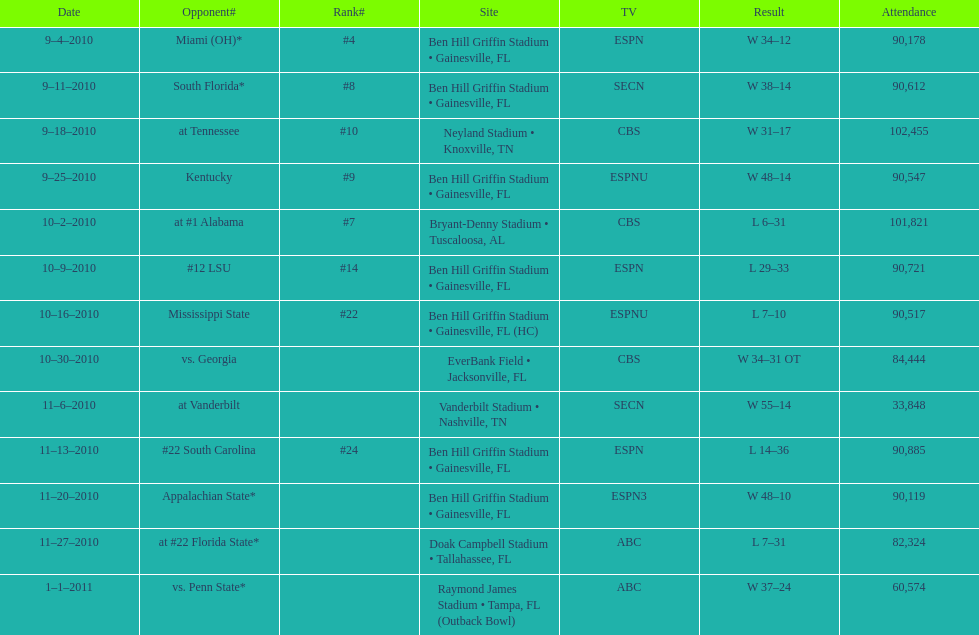What was the most the university of florida won by? 41 points. 